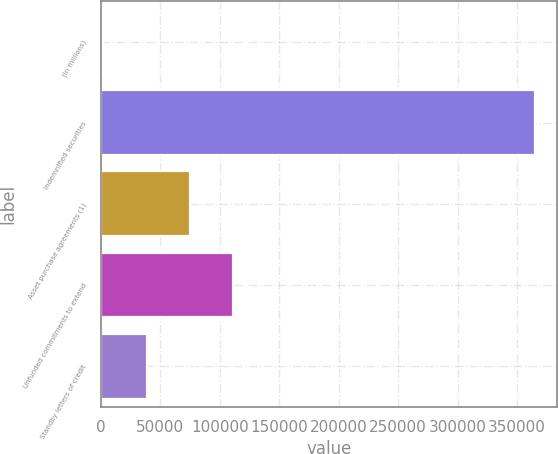<chart> <loc_0><loc_0><loc_500><loc_500><bar_chart><fcel>(In millions)<fcel>Indemnified securities<fcel>Asset purchase agreements (1)<fcel>Unfunded commitments to extend<fcel>Standby letters of credit<nl><fcel>2009<fcel>365251<fcel>74657.4<fcel>110982<fcel>38333.2<nl></chart> 